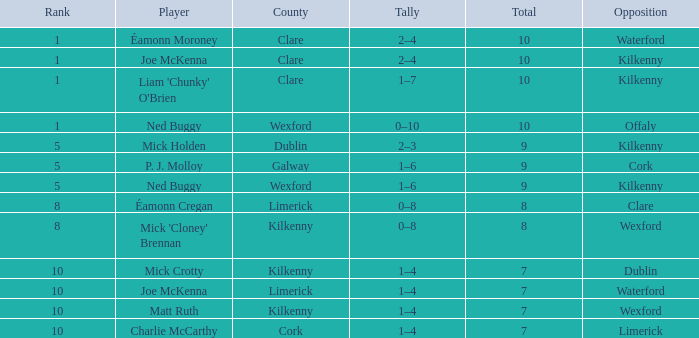Which County has a Rank larger than 8, and a Player of joe mckenna? Limerick. 